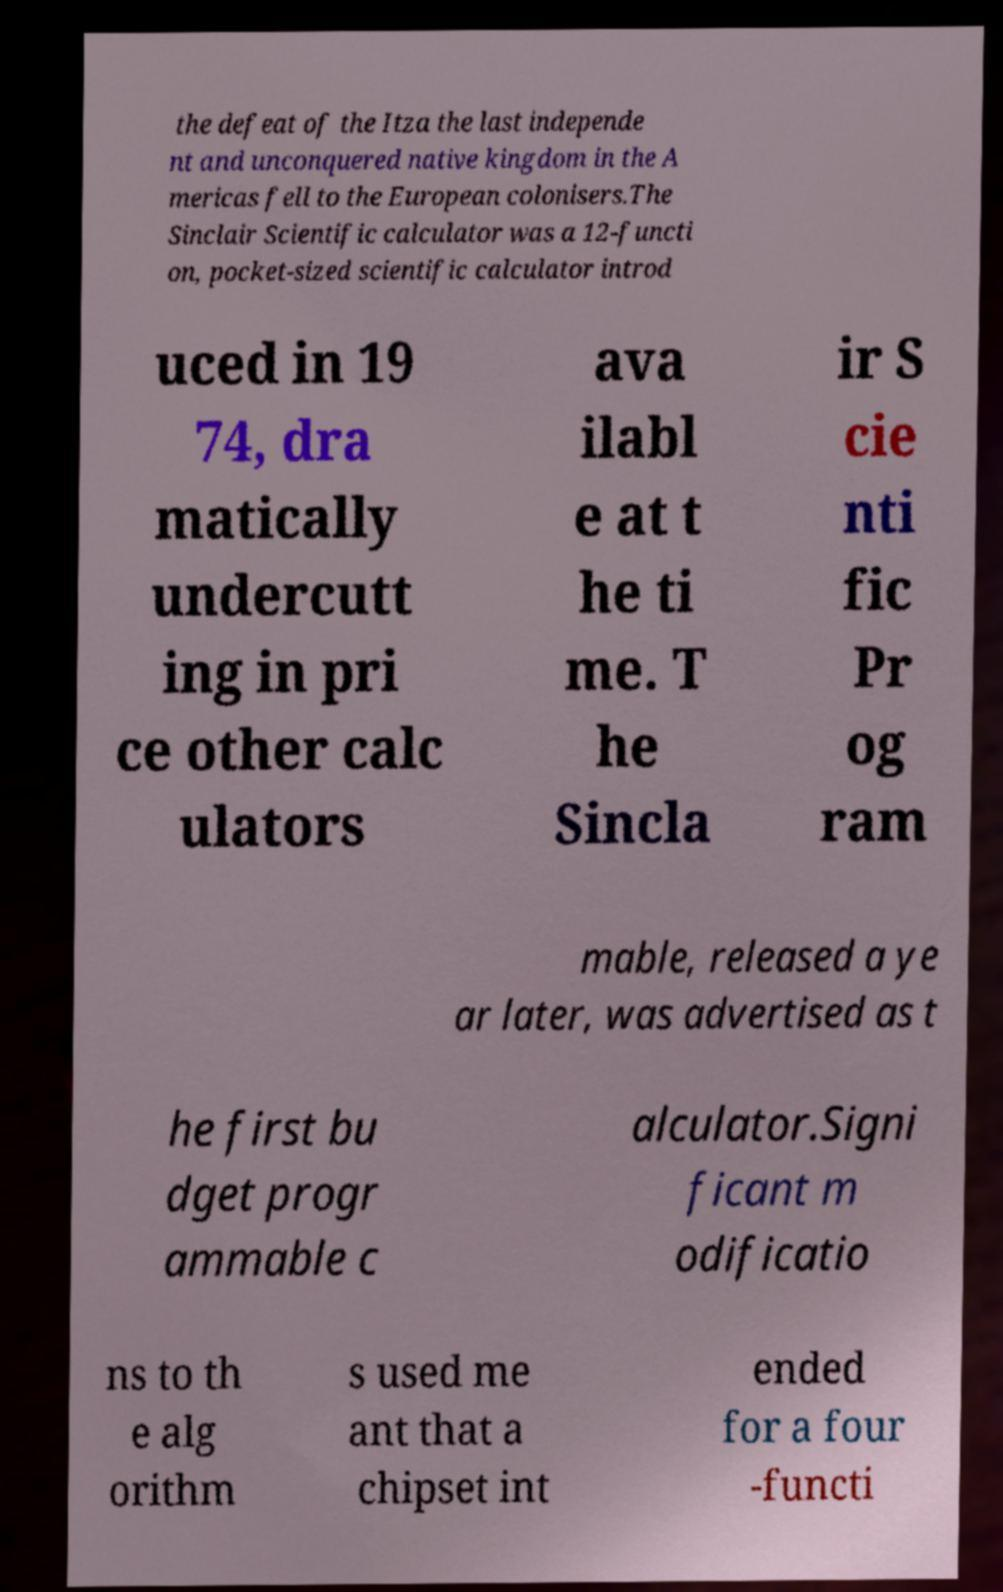Could you assist in decoding the text presented in this image and type it out clearly? the defeat of the Itza the last independe nt and unconquered native kingdom in the A mericas fell to the European colonisers.The Sinclair Scientific calculator was a 12-functi on, pocket-sized scientific calculator introd uced in 19 74, dra matically undercutt ing in pri ce other calc ulators ava ilabl e at t he ti me. T he Sincla ir S cie nti fic Pr og ram mable, released a ye ar later, was advertised as t he first bu dget progr ammable c alculator.Signi ficant m odificatio ns to th e alg orithm s used me ant that a chipset int ended for a four -functi 